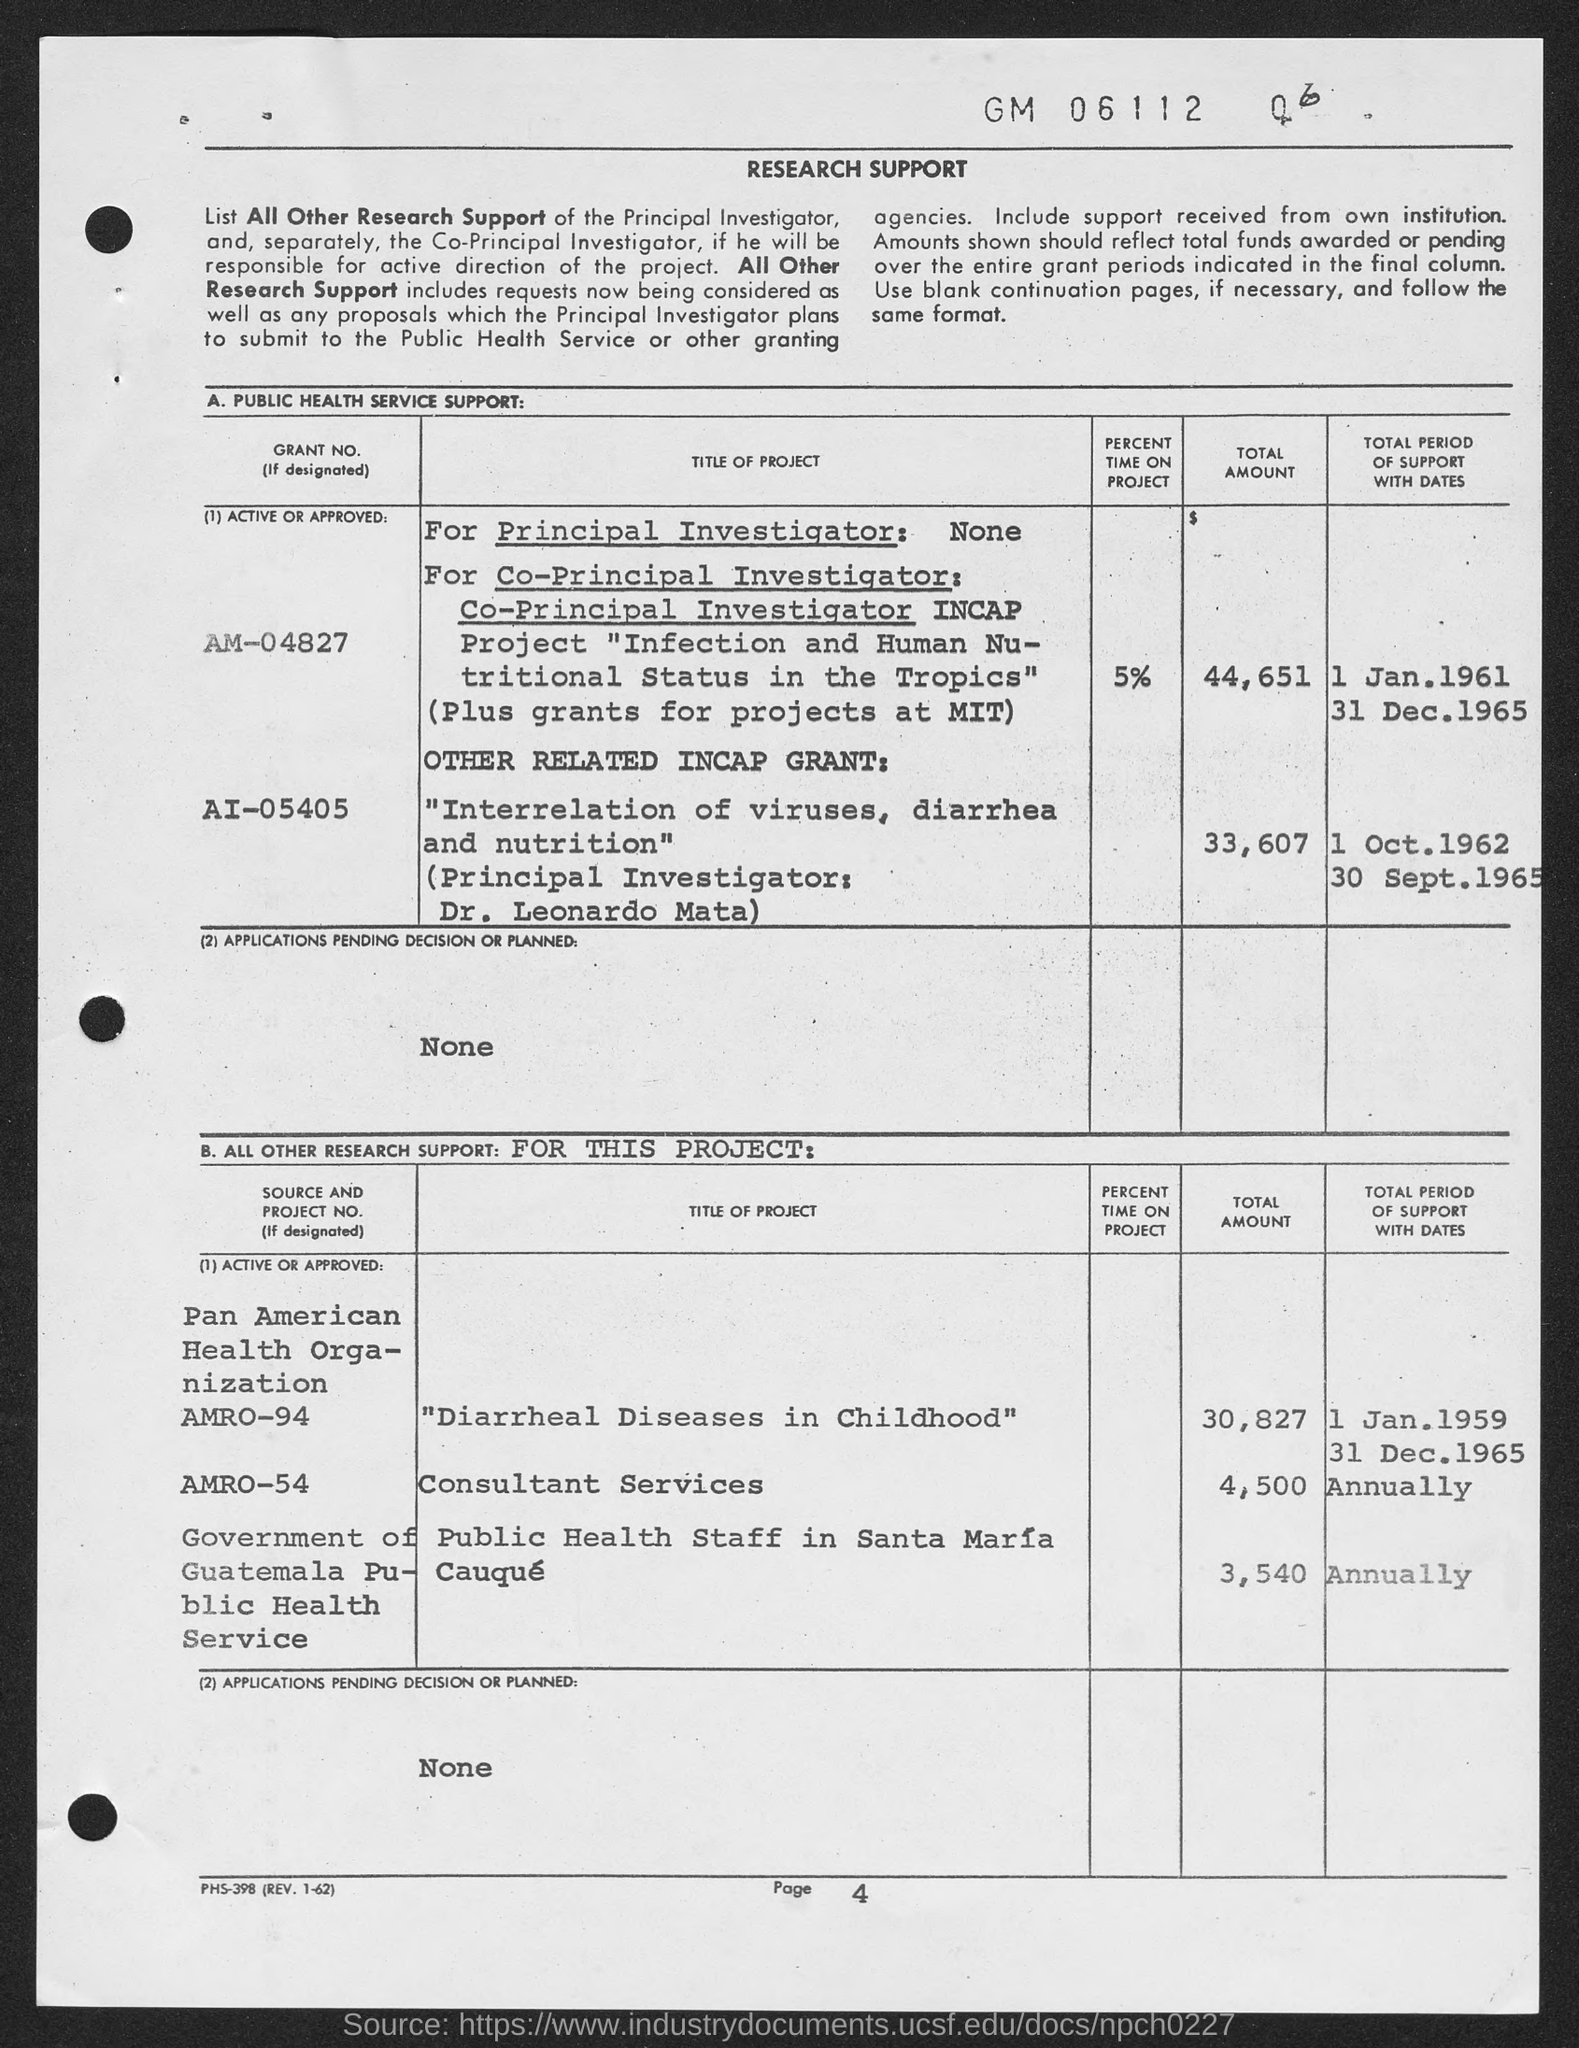What is the page no. at bottom of the page?
Your answer should be compact. Page 4. 